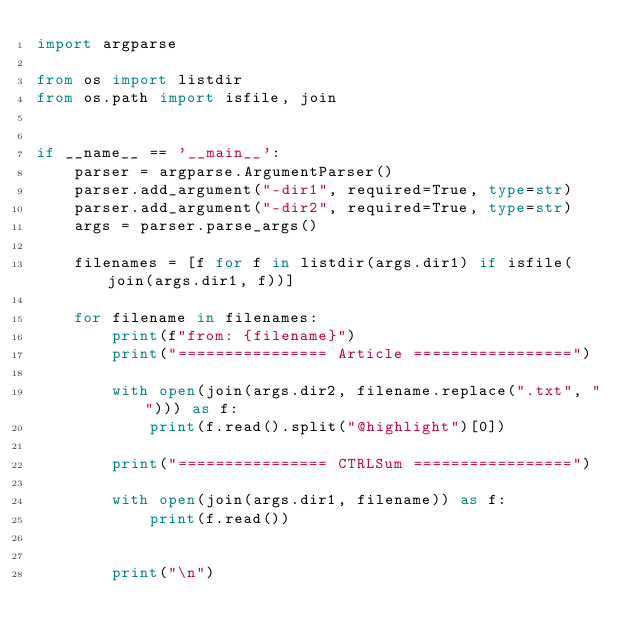<code> <loc_0><loc_0><loc_500><loc_500><_Python_>import argparse

from os import listdir
from os.path import isfile, join


if __name__ == '__main__':
    parser = argparse.ArgumentParser()
    parser.add_argument("-dir1", required=True, type=str)
    parser.add_argument("-dir2", required=True, type=str)
    args = parser.parse_args()

    filenames = [f for f in listdir(args.dir1) if isfile(join(args.dir1, f))]

    for filename in filenames:
        print(f"from: {filename}")
        print("================ Article =================")

        with open(join(args.dir2, filename.replace(".txt", ""))) as f:
            print(f.read().split("@highlight")[0])

        print("================ CTRLSum =================")

        with open(join(args.dir1, filename)) as f:
            print(f.read())

        
        print("\n")
</code> 